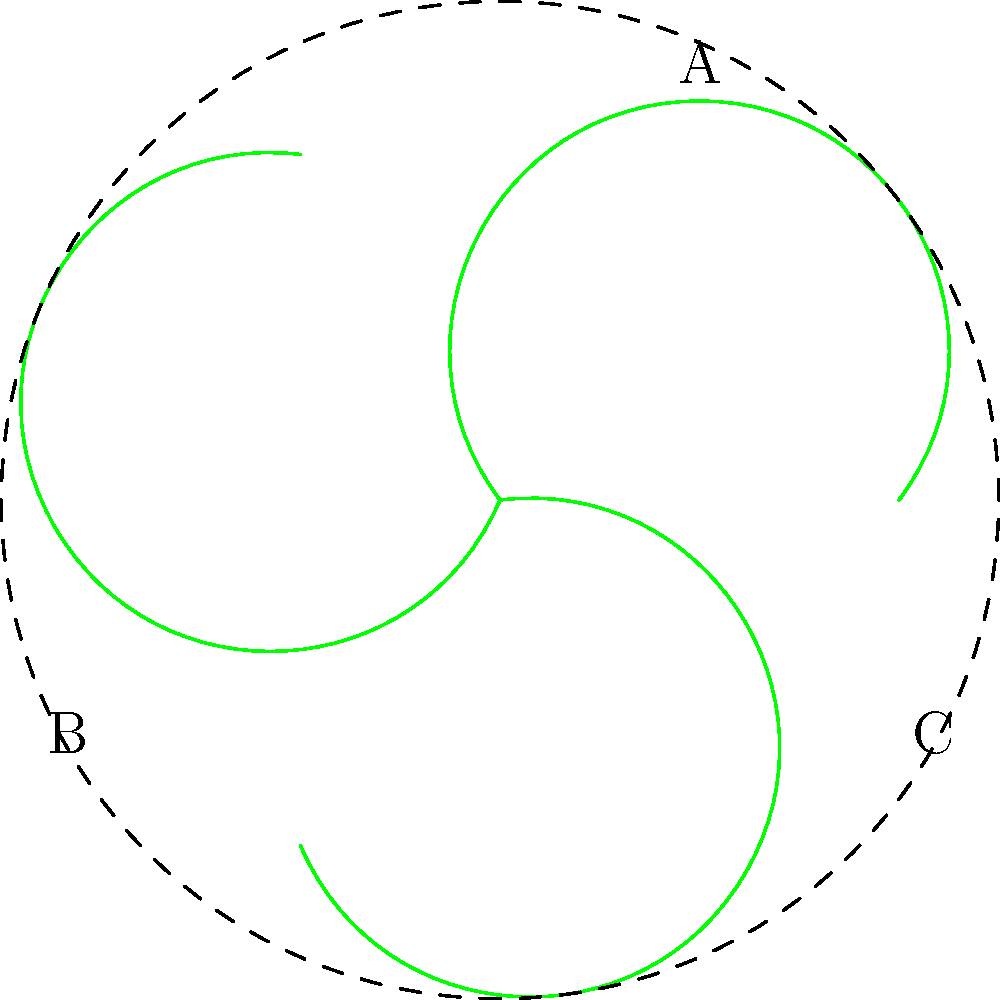In the illustrated diagram of a fynbos plant leaf arrangement, which type of phyllotaxy is represented, and how does this adaptation benefit the plant in its native environment? To answer this question, let's analyze the diagram step-by-step:

1. Observe the leaf arrangement: The diagram shows three leaves arranged around a central point, forming a circular pattern.

2. Identify the phyllotaxy: This arrangement represents whorled phyllotaxy, where three or more leaves emerge from a single node in a circular pattern.

3. Understand the benefits:
   a) Increased light interception: Whorled arrangement maximizes the plant's ability to capture sunlight from different angles.
   b) Reduced self-shading: Leaves are positioned to minimize overlap, ensuring each leaf receives adequate light.
   c) Efficient water use: The arrangement allows for better water distribution and reduces evaporation.
   d) Adaptation to harsh conditions: Fynbos plants often grow in nutrient-poor soils and dry conditions, making efficient resource use crucial.

4. Consider the fynbos environment: The Cape floral kingdom is known for its biodiversity and challenging growing conditions, including poor soils, seasonal drought, and frequent fires.

5. Connect the adaptation to the environment: The whorled arrangement helps fynbos plants maximize resource utilization in their harsh native habitat, contributing to their survival and the ecosystem's biodiversity.
Answer: Whorled phyllotaxy; maximizes light interception and resource efficiency in harsh fynbos environments. 